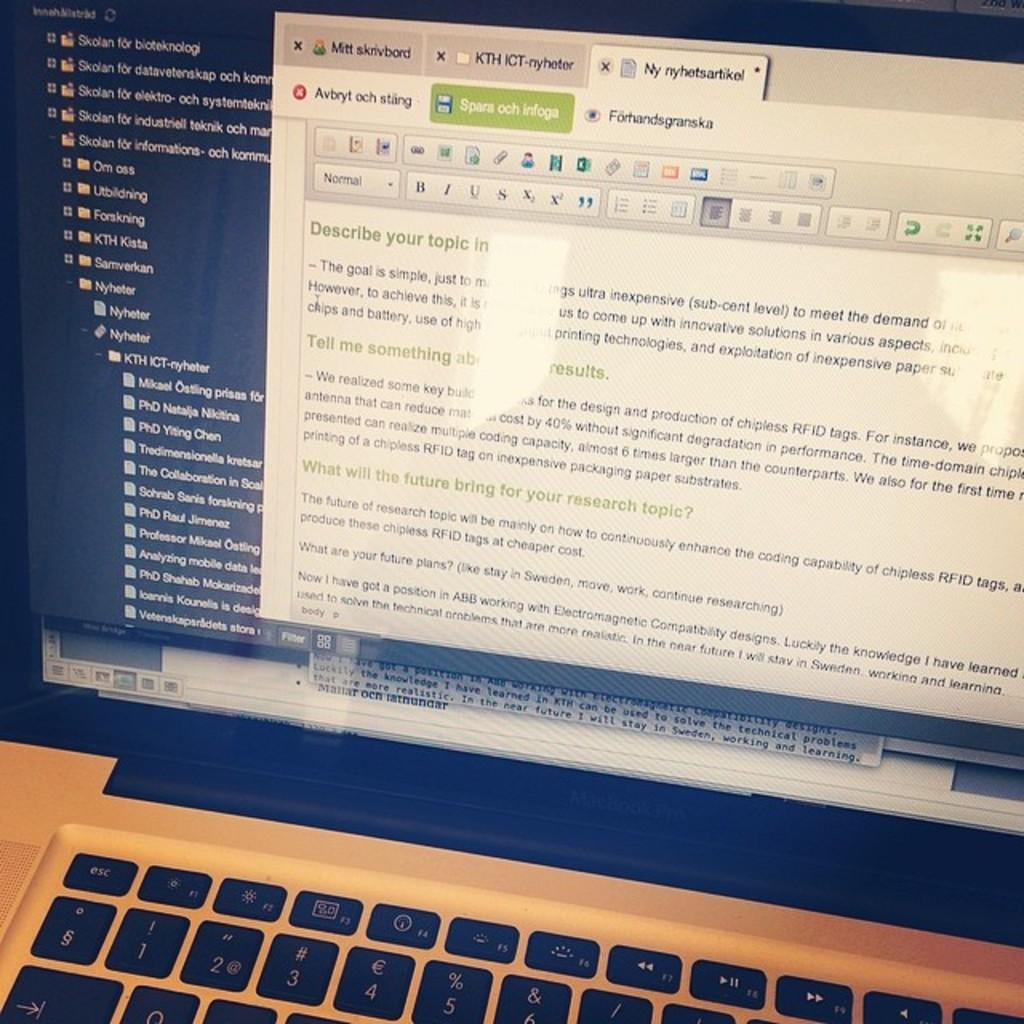What electronic device is visible in the image? There is a laptop in the image. What part of the laptop is used for typing? There is a keypad at the bottom of the laptop. What part of the laptop displays information? There is a screen in the front of the laptop. What type of bread is being sliced on the laptop? There is no bread present in the image; it features a laptop with a keypad and a screen. What type of writing instrument is being used on the laptop? There is no writing instrument present in the image; it features a laptop with a keypad and a screen. 